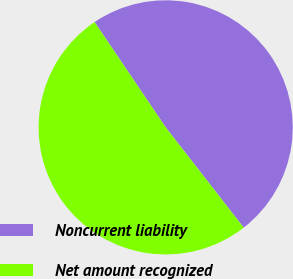Convert chart. <chart><loc_0><loc_0><loc_500><loc_500><pie_chart><fcel>Noncurrent liability<fcel>Net amount recognized<nl><fcel>48.93%<fcel>51.07%<nl></chart> 